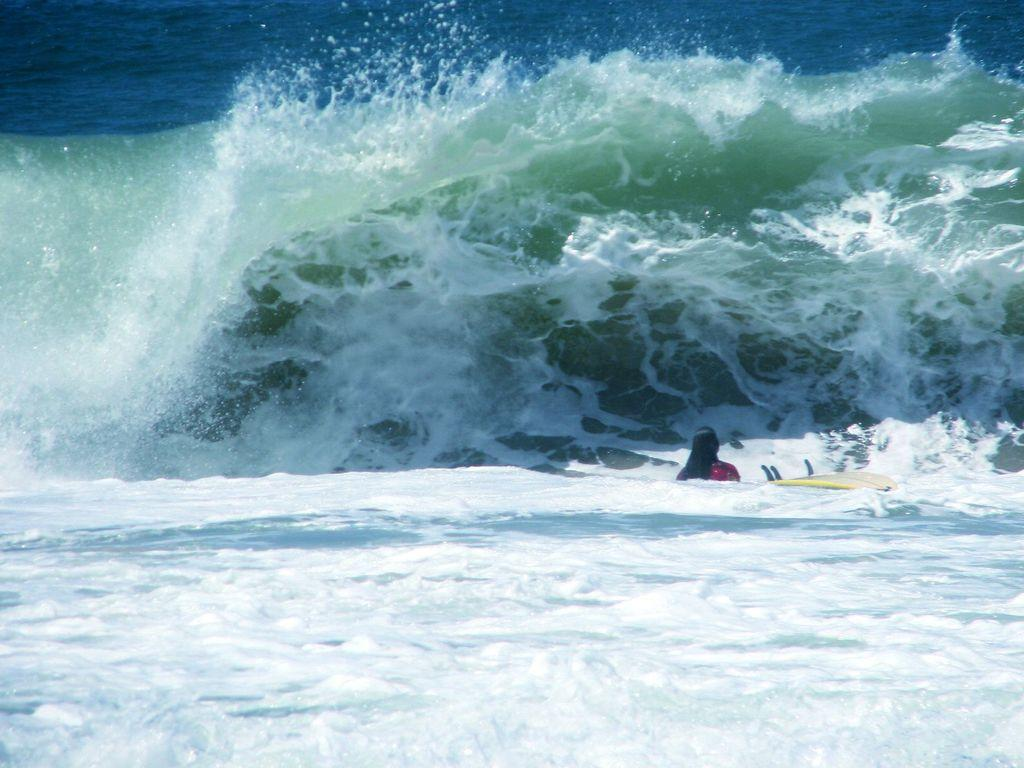What is the main element in the image? There is water in the image. What can be observed about the water's color? The water has white color tides. What activity is the person in the image engaged in? There is a person on a surfboard in the water. What is the color of the water in the background? The background of the image includes blue water. What type of haircut does the person on the surfboard have in the image? There is no information about the person's haircut in the image. How many eyes can be seen on the person on the surfboard in the image? The image does not show the person's eyes, so it cannot be determined. 